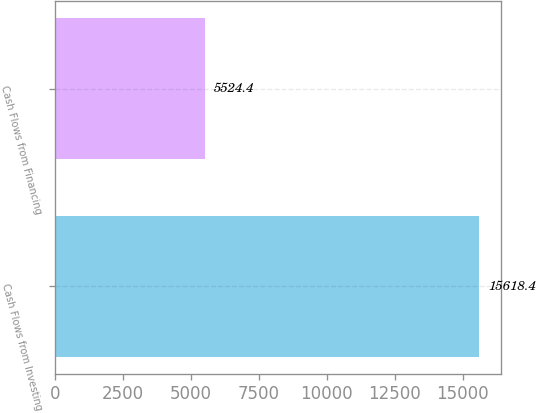Convert chart to OTSL. <chart><loc_0><loc_0><loc_500><loc_500><bar_chart><fcel>Cash Flows from Investing<fcel>Cash Flows from Financing<nl><fcel>15618.4<fcel>5524.4<nl></chart> 